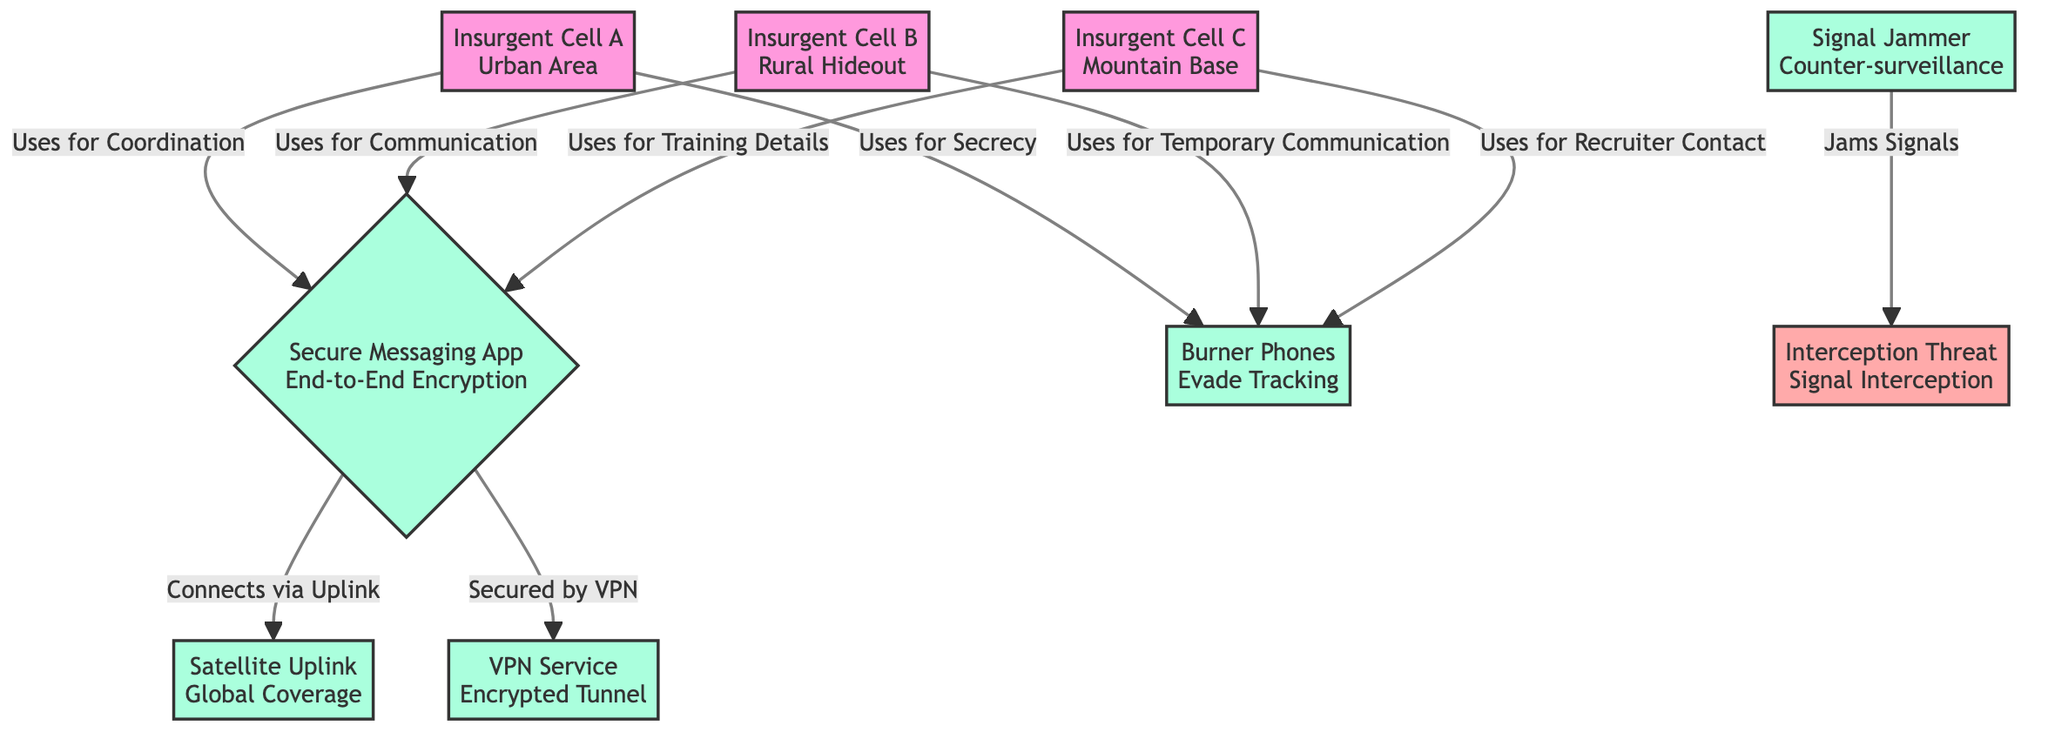What type of secure messaging app is used by the insurgent cells? The diagram shows that the secure messaging app has end-to-end encryption, indicating that messages are only readable by the sender and receiver.
Answer: Secure Messaging App End-to-End Encryption How many insurgent cells are depicted in the diagram? There are three insurgent cells labeled A, B, and C, visible in the diagram.
Answer: 3 What is the main function of the satellite uplink in the diagram? The satellite uplink is used for global coverage to connect with the secure messaging app, allowing the insurgent cells to communicate over a wide area.
Answer: Global Coverage Which device is used to evade tracking? The diagram indicates that burner phones are utilized by the insurgent cells specifically for evading tracking, as mentioned in their relationships.
Answer: Burner Phones Evade Tracking What is indicated as a threat to secure communications in the diagram? The diagram identifies signal interception as a threat, emphasizing the potential of intercepted communications between the insurgent cells.
Answer: Signal Interception What mechanism is used to secure the satellite uplink connection? The VPN service is indicated in the diagram as securing the satellite uplink connection through an encrypted tunnel, ensuring protection during communications.
Answer: VPN Service Encrypted Tunnel How do insurgent cells in rural hideouts primarily communicate? The diagram states that insurgent cell B uses the secure messaging app for communication, signifying their primary method of interaction.
Answer: Secure Messaging App What is the relationship between the signal jammer and the interception threat? The signal jammer is designed to jam signals which directly relates to the interception threat, as jamming signals prevents successful interception of communications.
Answer: Jams Signals What type of area does Insurgent Cell A operate in? Insurgent Cell A operates in an urban area, as explicitly noted next to the cell's label in the diagram.
Answer: Urban Area 